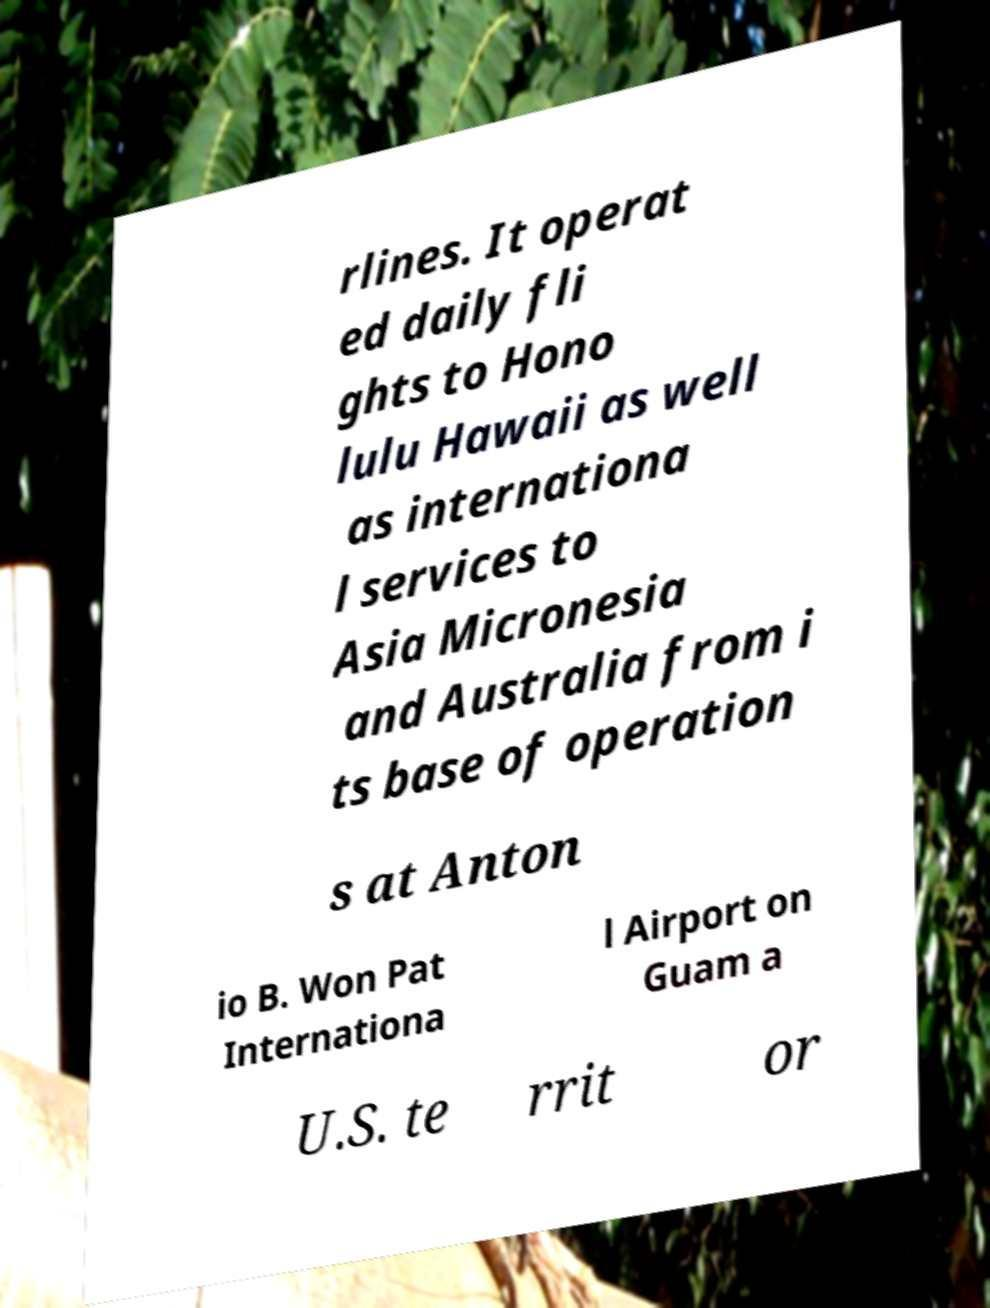Can you accurately transcribe the text from the provided image for me? rlines. It operat ed daily fli ghts to Hono lulu Hawaii as well as internationa l services to Asia Micronesia and Australia from i ts base of operation s at Anton io B. Won Pat Internationa l Airport on Guam a U.S. te rrit or 